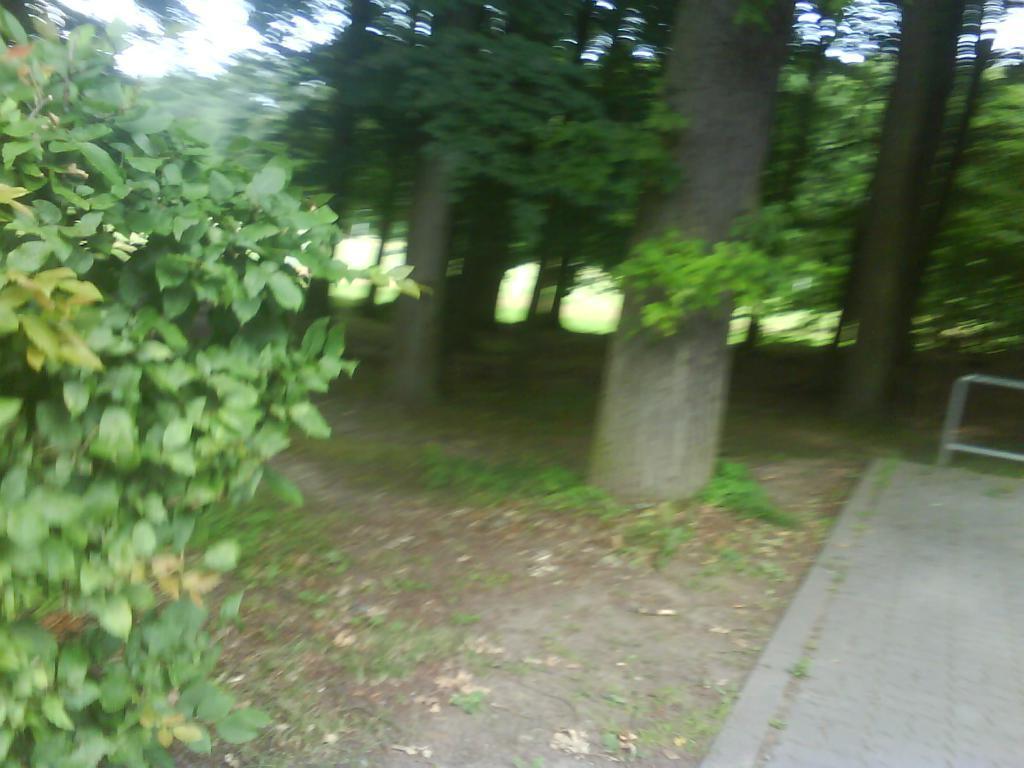Please provide a concise description of this image. In this picture I can see there are trees and there are plants, grass and there is soil on the floor. 